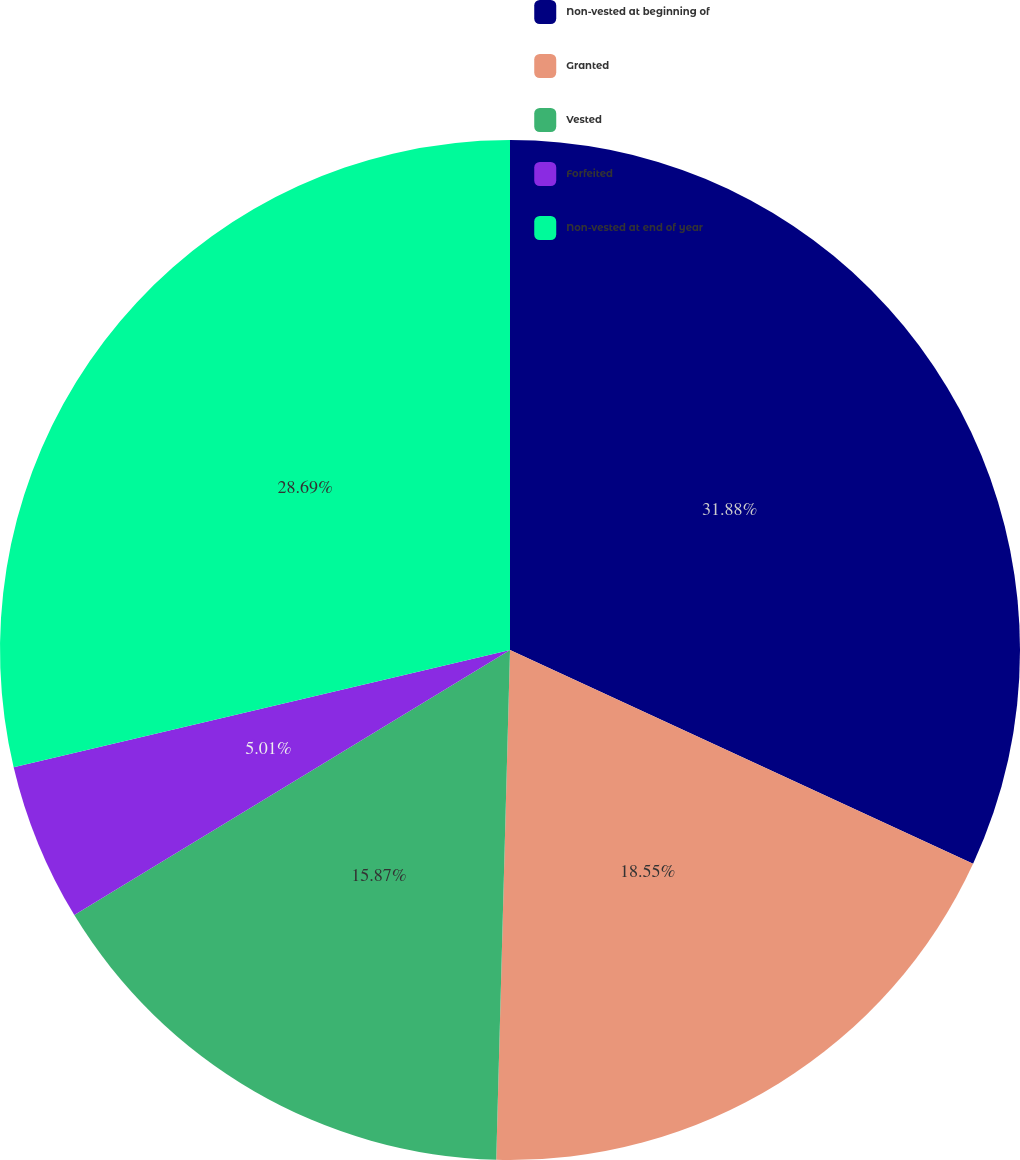Convert chart. <chart><loc_0><loc_0><loc_500><loc_500><pie_chart><fcel>Non-vested at beginning of<fcel>Granted<fcel>Vested<fcel>Forfeited<fcel>Non-vested at end of year<nl><fcel>31.88%<fcel>18.55%<fcel>15.87%<fcel>5.01%<fcel>28.69%<nl></chart> 